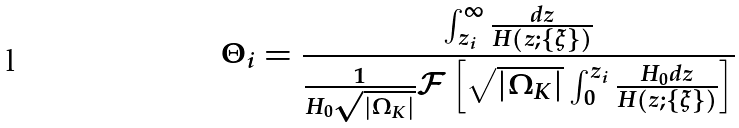Convert formula to latex. <formula><loc_0><loc_0><loc_500><loc_500>\Theta _ { i } = \frac { \int _ { z _ { i } } ^ { \infty } \frac { d z } { H ( z ; \{ \xi \} ) } } { \frac { 1 } { H _ { 0 } \sqrt { | { \Omega _ { K } } | } } { \mathcal { F } } \left [ \sqrt { | { \Omega _ { K } } | } \int _ { 0 } ^ { z _ { i } } \frac { H _ { 0 } d z } { H ( z ; \{ \xi \} ) } \right ] }</formula> 